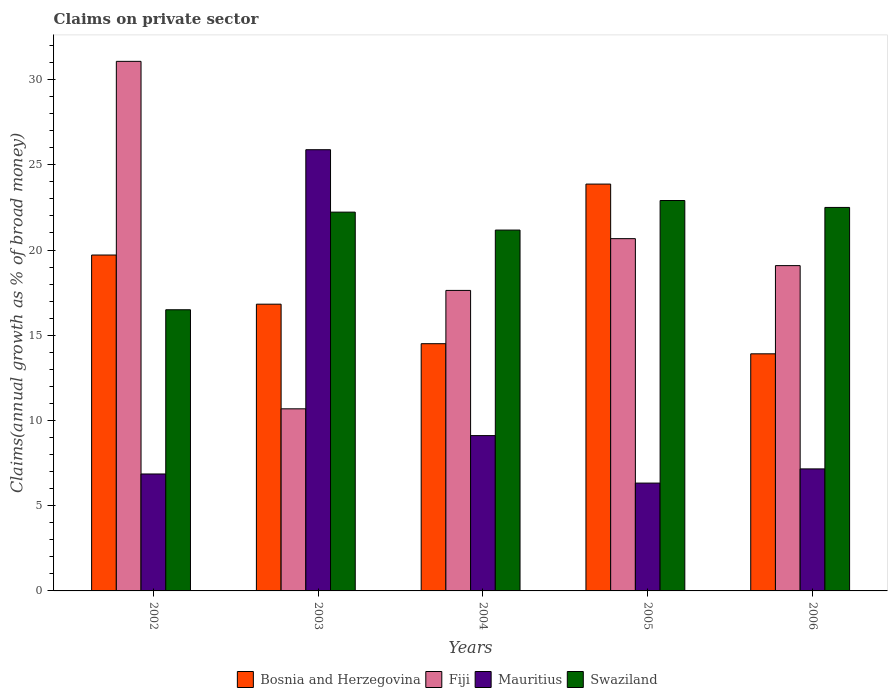Are the number of bars on each tick of the X-axis equal?
Ensure brevity in your answer.  Yes. How many bars are there on the 4th tick from the left?
Make the answer very short. 4. What is the percentage of broad money claimed on private sector in Swaziland in 2006?
Offer a very short reply. 22.5. Across all years, what is the maximum percentage of broad money claimed on private sector in Bosnia and Herzegovina?
Your response must be concise. 23.87. Across all years, what is the minimum percentage of broad money claimed on private sector in Swaziland?
Give a very brief answer. 16.49. In which year was the percentage of broad money claimed on private sector in Swaziland maximum?
Give a very brief answer. 2005. What is the total percentage of broad money claimed on private sector in Mauritius in the graph?
Offer a terse response. 55.34. What is the difference between the percentage of broad money claimed on private sector in Mauritius in 2005 and that in 2006?
Your answer should be compact. -0.83. What is the difference between the percentage of broad money claimed on private sector in Fiji in 2003 and the percentage of broad money claimed on private sector in Mauritius in 2004?
Make the answer very short. 1.57. What is the average percentage of broad money claimed on private sector in Mauritius per year?
Give a very brief answer. 11.07. In the year 2002, what is the difference between the percentage of broad money claimed on private sector in Fiji and percentage of broad money claimed on private sector in Bosnia and Herzegovina?
Keep it short and to the point. 11.36. What is the ratio of the percentage of broad money claimed on private sector in Fiji in 2003 to that in 2006?
Give a very brief answer. 0.56. Is the difference between the percentage of broad money claimed on private sector in Fiji in 2002 and 2003 greater than the difference between the percentage of broad money claimed on private sector in Bosnia and Herzegovina in 2002 and 2003?
Keep it short and to the point. Yes. What is the difference between the highest and the second highest percentage of broad money claimed on private sector in Bosnia and Herzegovina?
Provide a succinct answer. 4.16. What is the difference between the highest and the lowest percentage of broad money claimed on private sector in Swaziland?
Offer a terse response. 6.41. Is the sum of the percentage of broad money claimed on private sector in Bosnia and Herzegovina in 2005 and 2006 greater than the maximum percentage of broad money claimed on private sector in Mauritius across all years?
Offer a very short reply. Yes. What does the 1st bar from the left in 2006 represents?
Offer a terse response. Bosnia and Herzegovina. What does the 4th bar from the right in 2003 represents?
Your answer should be very brief. Bosnia and Herzegovina. Are all the bars in the graph horizontal?
Ensure brevity in your answer.  No. How many years are there in the graph?
Your answer should be compact. 5. Are the values on the major ticks of Y-axis written in scientific E-notation?
Your answer should be compact. No. Does the graph contain any zero values?
Provide a succinct answer. No. Does the graph contain grids?
Offer a terse response. No. How many legend labels are there?
Your answer should be compact. 4. How are the legend labels stacked?
Provide a short and direct response. Horizontal. What is the title of the graph?
Keep it short and to the point. Claims on private sector. What is the label or title of the X-axis?
Make the answer very short. Years. What is the label or title of the Y-axis?
Offer a terse response. Claims(annual growth as % of broad money). What is the Claims(annual growth as % of broad money) in Bosnia and Herzegovina in 2002?
Offer a terse response. 19.71. What is the Claims(annual growth as % of broad money) in Fiji in 2002?
Provide a succinct answer. 31.07. What is the Claims(annual growth as % of broad money) of Mauritius in 2002?
Ensure brevity in your answer.  6.86. What is the Claims(annual growth as % of broad money) of Swaziland in 2002?
Give a very brief answer. 16.49. What is the Claims(annual growth as % of broad money) in Bosnia and Herzegovina in 2003?
Ensure brevity in your answer.  16.82. What is the Claims(annual growth as % of broad money) in Fiji in 2003?
Give a very brief answer. 10.68. What is the Claims(annual growth as % of broad money) of Mauritius in 2003?
Give a very brief answer. 25.88. What is the Claims(annual growth as % of broad money) of Swaziland in 2003?
Offer a very short reply. 22.22. What is the Claims(annual growth as % of broad money) of Bosnia and Herzegovina in 2004?
Make the answer very short. 14.5. What is the Claims(annual growth as % of broad money) of Fiji in 2004?
Ensure brevity in your answer.  17.63. What is the Claims(annual growth as % of broad money) in Mauritius in 2004?
Offer a very short reply. 9.11. What is the Claims(annual growth as % of broad money) of Swaziland in 2004?
Make the answer very short. 21.17. What is the Claims(annual growth as % of broad money) in Bosnia and Herzegovina in 2005?
Make the answer very short. 23.87. What is the Claims(annual growth as % of broad money) in Fiji in 2005?
Ensure brevity in your answer.  20.67. What is the Claims(annual growth as % of broad money) in Mauritius in 2005?
Offer a very short reply. 6.33. What is the Claims(annual growth as % of broad money) of Swaziland in 2005?
Provide a short and direct response. 22.9. What is the Claims(annual growth as % of broad money) in Bosnia and Herzegovina in 2006?
Your response must be concise. 13.91. What is the Claims(annual growth as % of broad money) of Fiji in 2006?
Give a very brief answer. 19.09. What is the Claims(annual growth as % of broad money) in Mauritius in 2006?
Your answer should be very brief. 7.16. What is the Claims(annual growth as % of broad money) in Swaziland in 2006?
Your response must be concise. 22.5. Across all years, what is the maximum Claims(annual growth as % of broad money) of Bosnia and Herzegovina?
Your answer should be very brief. 23.87. Across all years, what is the maximum Claims(annual growth as % of broad money) in Fiji?
Offer a terse response. 31.07. Across all years, what is the maximum Claims(annual growth as % of broad money) of Mauritius?
Provide a succinct answer. 25.88. Across all years, what is the maximum Claims(annual growth as % of broad money) in Swaziland?
Provide a short and direct response. 22.9. Across all years, what is the minimum Claims(annual growth as % of broad money) of Bosnia and Herzegovina?
Keep it short and to the point. 13.91. Across all years, what is the minimum Claims(annual growth as % of broad money) of Fiji?
Your response must be concise. 10.68. Across all years, what is the minimum Claims(annual growth as % of broad money) in Mauritius?
Ensure brevity in your answer.  6.33. Across all years, what is the minimum Claims(annual growth as % of broad money) in Swaziland?
Make the answer very short. 16.49. What is the total Claims(annual growth as % of broad money) in Bosnia and Herzegovina in the graph?
Your answer should be compact. 88.81. What is the total Claims(annual growth as % of broad money) of Fiji in the graph?
Provide a short and direct response. 99.13. What is the total Claims(annual growth as % of broad money) of Mauritius in the graph?
Offer a terse response. 55.34. What is the total Claims(annual growth as % of broad money) of Swaziland in the graph?
Provide a succinct answer. 105.29. What is the difference between the Claims(annual growth as % of broad money) in Bosnia and Herzegovina in 2002 and that in 2003?
Keep it short and to the point. 2.88. What is the difference between the Claims(annual growth as % of broad money) in Fiji in 2002 and that in 2003?
Provide a short and direct response. 20.39. What is the difference between the Claims(annual growth as % of broad money) of Mauritius in 2002 and that in 2003?
Provide a short and direct response. -19.02. What is the difference between the Claims(annual growth as % of broad money) of Swaziland in 2002 and that in 2003?
Ensure brevity in your answer.  -5.73. What is the difference between the Claims(annual growth as % of broad money) in Bosnia and Herzegovina in 2002 and that in 2004?
Offer a terse response. 5.2. What is the difference between the Claims(annual growth as % of broad money) in Fiji in 2002 and that in 2004?
Your answer should be very brief. 13.44. What is the difference between the Claims(annual growth as % of broad money) of Mauritius in 2002 and that in 2004?
Your answer should be very brief. -2.25. What is the difference between the Claims(annual growth as % of broad money) of Swaziland in 2002 and that in 2004?
Your response must be concise. -4.68. What is the difference between the Claims(annual growth as % of broad money) of Bosnia and Herzegovina in 2002 and that in 2005?
Make the answer very short. -4.16. What is the difference between the Claims(annual growth as % of broad money) in Fiji in 2002 and that in 2005?
Provide a succinct answer. 10.4. What is the difference between the Claims(annual growth as % of broad money) in Mauritius in 2002 and that in 2005?
Offer a very short reply. 0.53. What is the difference between the Claims(annual growth as % of broad money) in Swaziland in 2002 and that in 2005?
Provide a short and direct response. -6.41. What is the difference between the Claims(annual growth as % of broad money) of Bosnia and Herzegovina in 2002 and that in 2006?
Give a very brief answer. 5.8. What is the difference between the Claims(annual growth as % of broad money) in Fiji in 2002 and that in 2006?
Ensure brevity in your answer.  11.98. What is the difference between the Claims(annual growth as % of broad money) in Mauritius in 2002 and that in 2006?
Provide a short and direct response. -0.3. What is the difference between the Claims(annual growth as % of broad money) of Swaziland in 2002 and that in 2006?
Ensure brevity in your answer.  -6. What is the difference between the Claims(annual growth as % of broad money) in Bosnia and Herzegovina in 2003 and that in 2004?
Give a very brief answer. 2.32. What is the difference between the Claims(annual growth as % of broad money) in Fiji in 2003 and that in 2004?
Your response must be concise. -6.95. What is the difference between the Claims(annual growth as % of broad money) of Mauritius in 2003 and that in 2004?
Keep it short and to the point. 16.77. What is the difference between the Claims(annual growth as % of broad money) of Swaziland in 2003 and that in 2004?
Make the answer very short. 1.05. What is the difference between the Claims(annual growth as % of broad money) in Bosnia and Herzegovina in 2003 and that in 2005?
Your response must be concise. -7.05. What is the difference between the Claims(annual growth as % of broad money) in Fiji in 2003 and that in 2005?
Provide a succinct answer. -9.98. What is the difference between the Claims(annual growth as % of broad money) in Mauritius in 2003 and that in 2005?
Offer a very short reply. 19.56. What is the difference between the Claims(annual growth as % of broad money) in Swaziland in 2003 and that in 2005?
Your response must be concise. -0.68. What is the difference between the Claims(annual growth as % of broad money) in Bosnia and Herzegovina in 2003 and that in 2006?
Your answer should be compact. 2.91. What is the difference between the Claims(annual growth as % of broad money) of Fiji in 2003 and that in 2006?
Provide a short and direct response. -8.4. What is the difference between the Claims(annual growth as % of broad money) in Mauritius in 2003 and that in 2006?
Your answer should be very brief. 18.73. What is the difference between the Claims(annual growth as % of broad money) in Swaziland in 2003 and that in 2006?
Your answer should be very brief. -0.28. What is the difference between the Claims(annual growth as % of broad money) of Bosnia and Herzegovina in 2004 and that in 2005?
Your answer should be compact. -9.36. What is the difference between the Claims(annual growth as % of broad money) in Fiji in 2004 and that in 2005?
Offer a very short reply. -3.04. What is the difference between the Claims(annual growth as % of broad money) in Mauritius in 2004 and that in 2005?
Your answer should be compact. 2.79. What is the difference between the Claims(annual growth as % of broad money) of Swaziland in 2004 and that in 2005?
Provide a succinct answer. -1.73. What is the difference between the Claims(annual growth as % of broad money) in Bosnia and Herzegovina in 2004 and that in 2006?
Give a very brief answer. 0.59. What is the difference between the Claims(annual growth as % of broad money) in Fiji in 2004 and that in 2006?
Your answer should be very brief. -1.45. What is the difference between the Claims(annual growth as % of broad money) in Mauritius in 2004 and that in 2006?
Offer a very short reply. 1.95. What is the difference between the Claims(annual growth as % of broad money) of Swaziland in 2004 and that in 2006?
Keep it short and to the point. -1.33. What is the difference between the Claims(annual growth as % of broad money) in Bosnia and Herzegovina in 2005 and that in 2006?
Provide a succinct answer. 9.96. What is the difference between the Claims(annual growth as % of broad money) of Fiji in 2005 and that in 2006?
Offer a terse response. 1.58. What is the difference between the Claims(annual growth as % of broad money) in Mauritius in 2005 and that in 2006?
Ensure brevity in your answer.  -0.83. What is the difference between the Claims(annual growth as % of broad money) of Swaziland in 2005 and that in 2006?
Give a very brief answer. 0.41. What is the difference between the Claims(annual growth as % of broad money) in Bosnia and Herzegovina in 2002 and the Claims(annual growth as % of broad money) in Fiji in 2003?
Your answer should be very brief. 9.02. What is the difference between the Claims(annual growth as % of broad money) of Bosnia and Herzegovina in 2002 and the Claims(annual growth as % of broad money) of Mauritius in 2003?
Provide a succinct answer. -6.18. What is the difference between the Claims(annual growth as % of broad money) in Bosnia and Herzegovina in 2002 and the Claims(annual growth as % of broad money) in Swaziland in 2003?
Offer a very short reply. -2.52. What is the difference between the Claims(annual growth as % of broad money) in Fiji in 2002 and the Claims(annual growth as % of broad money) in Mauritius in 2003?
Keep it short and to the point. 5.18. What is the difference between the Claims(annual growth as % of broad money) in Fiji in 2002 and the Claims(annual growth as % of broad money) in Swaziland in 2003?
Offer a very short reply. 8.85. What is the difference between the Claims(annual growth as % of broad money) in Mauritius in 2002 and the Claims(annual growth as % of broad money) in Swaziland in 2003?
Offer a very short reply. -15.36. What is the difference between the Claims(annual growth as % of broad money) of Bosnia and Herzegovina in 2002 and the Claims(annual growth as % of broad money) of Fiji in 2004?
Offer a very short reply. 2.08. What is the difference between the Claims(annual growth as % of broad money) of Bosnia and Herzegovina in 2002 and the Claims(annual growth as % of broad money) of Mauritius in 2004?
Keep it short and to the point. 10.59. What is the difference between the Claims(annual growth as % of broad money) of Bosnia and Herzegovina in 2002 and the Claims(annual growth as % of broad money) of Swaziland in 2004?
Give a very brief answer. -1.46. What is the difference between the Claims(annual growth as % of broad money) of Fiji in 2002 and the Claims(annual growth as % of broad money) of Mauritius in 2004?
Your answer should be very brief. 21.96. What is the difference between the Claims(annual growth as % of broad money) of Fiji in 2002 and the Claims(annual growth as % of broad money) of Swaziland in 2004?
Your answer should be compact. 9.9. What is the difference between the Claims(annual growth as % of broad money) in Mauritius in 2002 and the Claims(annual growth as % of broad money) in Swaziland in 2004?
Give a very brief answer. -14.31. What is the difference between the Claims(annual growth as % of broad money) of Bosnia and Herzegovina in 2002 and the Claims(annual growth as % of broad money) of Fiji in 2005?
Your response must be concise. -0.96. What is the difference between the Claims(annual growth as % of broad money) in Bosnia and Herzegovina in 2002 and the Claims(annual growth as % of broad money) in Mauritius in 2005?
Give a very brief answer. 13.38. What is the difference between the Claims(annual growth as % of broad money) in Bosnia and Herzegovina in 2002 and the Claims(annual growth as % of broad money) in Swaziland in 2005?
Provide a succinct answer. -3.2. What is the difference between the Claims(annual growth as % of broad money) of Fiji in 2002 and the Claims(annual growth as % of broad money) of Mauritius in 2005?
Your answer should be compact. 24.74. What is the difference between the Claims(annual growth as % of broad money) of Fiji in 2002 and the Claims(annual growth as % of broad money) of Swaziland in 2005?
Give a very brief answer. 8.16. What is the difference between the Claims(annual growth as % of broad money) in Mauritius in 2002 and the Claims(annual growth as % of broad money) in Swaziland in 2005?
Provide a succinct answer. -16.04. What is the difference between the Claims(annual growth as % of broad money) in Bosnia and Herzegovina in 2002 and the Claims(annual growth as % of broad money) in Fiji in 2006?
Give a very brief answer. 0.62. What is the difference between the Claims(annual growth as % of broad money) in Bosnia and Herzegovina in 2002 and the Claims(annual growth as % of broad money) in Mauritius in 2006?
Ensure brevity in your answer.  12.55. What is the difference between the Claims(annual growth as % of broad money) of Bosnia and Herzegovina in 2002 and the Claims(annual growth as % of broad money) of Swaziland in 2006?
Offer a very short reply. -2.79. What is the difference between the Claims(annual growth as % of broad money) of Fiji in 2002 and the Claims(annual growth as % of broad money) of Mauritius in 2006?
Ensure brevity in your answer.  23.91. What is the difference between the Claims(annual growth as % of broad money) of Fiji in 2002 and the Claims(annual growth as % of broad money) of Swaziland in 2006?
Give a very brief answer. 8.57. What is the difference between the Claims(annual growth as % of broad money) of Mauritius in 2002 and the Claims(annual growth as % of broad money) of Swaziland in 2006?
Make the answer very short. -15.64. What is the difference between the Claims(annual growth as % of broad money) of Bosnia and Herzegovina in 2003 and the Claims(annual growth as % of broad money) of Fiji in 2004?
Make the answer very short. -0.81. What is the difference between the Claims(annual growth as % of broad money) of Bosnia and Herzegovina in 2003 and the Claims(annual growth as % of broad money) of Mauritius in 2004?
Ensure brevity in your answer.  7.71. What is the difference between the Claims(annual growth as % of broad money) of Bosnia and Herzegovina in 2003 and the Claims(annual growth as % of broad money) of Swaziland in 2004?
Keep it short and to the point. -4.35. What is the difference between the Claims(annual growth as % of broad money) in Fiji in 2003 and the Claims(annual growth as % of broad money) in Mauritius in 2004?
Offer a very short reply. 1.57. What is the difference between the Claims(annual growth as % of broad money) of Fiji in 2003 and the Claims(annual growth as % of broad money) of Swaziland in 2004?
Keep it short and to the point. -10.49. What is the difference between the Claims(annual growth as % of broad money) of Mauritius in 2003 and the Claims(annual growth as % of broad money) of Swaziland in 2004?
Provide a short and direct response. 4.71. What is the difference between the Claims(annual growth as % of broad money) in Bosnia and Herzegovina in 2003 and the Claims(annual growth as % of broad money) in Fiji in 2005?
Offer a very short reply. -3.84. What is the difference between the Claims(annual growth as % of broad money) of Bosnia and Herzegovina in 2003 and the Claims(annual growth as % of broad money) of Mauritius in 2005?
Ensure brevity in your answer.  10.5. What is the difference between the Claims(annual growth as % of broad money) in Bosnia and Herzegovina in 2003 and the Claims(annual growth as % of broad money) in Swaziland in 2005?
Ensure brevity in your answer.  -6.08. What is the difference between the Claims(annual growth as % of broad money) in Fiji in 2003 and the Claims(annual growth as % of broad money) in Mauritius in 2005?
Your response must be concise. 4.36. What is the difference between the Claims(annual growth as % of broad money) of Fiji in 2003 and the Claims(annual growth as % of broad money) of Swaziland in 2005?
Provide a succinct answer. -12.22. What is the difference between the Claims(annual growth as % of broad money) in Mauritius in 2003 and the Claims(annual growth as % of broad money) in Swaziland in 2005?
Give a very brief answer. 2.98. What is the difference between the Claims(annual growth as % of broad money) of Bosnia and Herzegovina in 2003 and the Claims(annual growth as % of broad money) of Fiji in 2006?
Offer a very short reply. -2.26. What is the difference between the Claims(annual growth as % of broad money) in Bosnia and Herzegovina in 2003 and the Claims(annual growth as % of broad money) in Mauritius in 2006?
Keep it short and to the point. 9.66. What is the difference between the Claims(annual growth as % of broad money) in Bosnia and Herzegovina in 2003 and the Claims(annual growth as % of broad money) in Swaziland in 2006?
Keep it short and to the point. -5.68. What is the difference between the Claims(annual growth as % of broad money) in Fiji in 2003 and the Claims(annual growth as % of broad money) in Mauritius in 2006?
Provide a short and direct response. 3.52. What is the difference between the Claims(annual growth as % of broad money) of Fiji in 2003 and the Claims(annual growth as % of broad money) of Swaziland in 2006?
Give a very brief answer. -11.82. What is the difference between the Claims(annual growth as % of broad money) of Mauritius in 2003 and the Claims(annual growth as % of broad money) of Swaziland in 2006?
Your answer should be very brief. 3.39. What is the difference between the Claims(annual growth as % of broad money) of Bosnia and Herzegovina in 2004 and the Claims(annual growth as % of broad money) of Fiji in 2005?
Provide a succinct answer. -6.16. What is the difference between the Claims(annual growth as % of broad money) of Bosnia and Herzegovina in 2004 and the Claims(annual growth as % of broad money) of Mauritius in 2005?
Make the answer very short. 8.18. What is the difference between the Claims(annual growth as % of broad money) of Bosnia and Herzegovina in 2004 and the Claims(annual growth as % of broad money) of Swaziland in 2005?
Make the answer very short. -8.4. What is the difference between the Claims(annual growth as % of broad money) of Fiji in 2004 and the Claims(annual growth as % of broad money) of Mauritius in 2005?
Provide a succinct answer. 11.3. What is the difference between the Claims(annual growth as % of broad money) of Fiji in 2004 and the Claims(annual growth as % of broad money) of Swaziland in 2005?
Your answer should be very brief. -5.27. What is the difference between the Claims(annual growth as % of broad money) of Mauritius in 2004 and the Claims(annual growth as % of broad money) of Swaziland in 2005?
Your answer should be compact. -13.79. What is the difference between the Claims(annual growth as % of broad money) of Bosnia and Herzegovina in 2004 and the Claims(annual growth as % of broad money) of Fiji in 2006?
Make the answer very short. -4.58. What is the difference between the Claims(annual growth as % of broad money) of Bosnia and Herzegovina in 2004 and the Claims(annual growth as % of broad money) of Mauritius in 2006?
Give a very brief answer. 7.35. What is the difference between the Claims(annual growth as % of broad money) in Bosnia and Herzegovina in 2004 and the Claims(annual growth as % of broad money) in Swaziland in 2006?
Make the answer very short. -8. What is the difference between the Claims(annual growth as % of broad money) in Fiji in 2004 and the Claims(annual growth as % of broad money) in Mauritius in 2006?
Offer a terse response. 10.47. What is the difference between the Claims(annual growth as % of broad money) of Fiji in 2004 and the Claims(annual growth as % of broad money) of Swaziland in 2006?
Ensure brevity in your answer.  -4.87. What is the difference between the Claims(annual growth as % of broad money) in Mauritius in 2004 and the Claims(annual growth as % of broad money) in Swaziland in 2006?
Your response must be concise. -13.39. What is the difference between the Claims(annual growth as % of broad money) in Bosnia and Herzegovina in 2005 and the Claims(annual growth as % of broad money) in Fiji in 2006?
Provide a succinct answer. 4.78. What is the difference between the Claims(annual growth as % of broad money) in Bosnia and Herzegovina in 2005 and the Claims(annual growth as % of broad money) in Mauritius in 2006?
Make the answer very short. 16.71. What is the difference between the Claims(annual growth as % of broad money) of Bosnia and Herzegovina in 2005 and the Claims(annual growth as % of broad money) of Swaziland in 2006?
Ensure brevity in your answer.  1.37. What is the difference between the Claims(annual growth as % of broad money) in Fiji in 2005 and the Claims(annual growth as % of broad money) in Mauritius in 2006?
Offer a terse response. 13.51. What is the difference between the Claims(annual growth as % of broad money) of Fiji in 2005 and the Claims(annual growth as % of broad money) of Swaziland in 2006?
Keep it short and to the point. -1.83. What is the difference between the Claims(annual growth as % of broad money) of Mauritius in 2005 and the Claims(annual growth as % of broad money) of Swaziland in 2006?
Provide a succinct answer. -16.17. What is the average Claims(annual growth as % of broad money) of Bosnia and Herzegovina per year?
Provide a short and direct response. 17.76. What is the average Claims(annual growth as % of broad money) in Fiji per year?
Your response must be concise. 19.83. What is the average Claims(annual growth as % of broad money) of Mauritius per year?
Your answer should be very brief. 11.07. What is the average Claims(annual growth as % of broad money) in Swaziland per year?
Your response must be concise. 21.06. In the year 2002, what is the difference between the Claims(annual growth as % of broad money) of Bosnia and Herzegovina and Claims(annual growth as % of broad money) of Fiji?
Make the answer very short. -11.36. In the year 2002, what is the difference between the Claims(annual growth as % of broad money) in Bosnia and Herzegovina and Claims(annual growth as % of broad money) in Mauritius?
Provide a succinct answer. 12.85. In the year 2002, what is the difference between the Claims(annual growth as % of broad money) of Bosnia and Herzegovina and Claims(annual growth as % of broad money) of Swaziland?
Keep it short and to the point. 3.21. In the year 2002, what is the difference between the Claims(annual growth as % of broad money) of Fiji and Claims(annual growth as % of broad money) of Mauritius?
Your answer should be compact. 24.21. In the year 2002, what is the difference between the Claims(annual growth as % of broad money) of Fiji and Claims(annual growth as % of broad money) of Swaziland?
Provide a short and direct response. 14.57. In the year 2002, what is the difference between the Claims(annual growth as % of broad money) in Mauritius and Claims(annual growth as % of broad money) in Swaziland?
Provide a succinct answer. -9.63. In the year 2003, what is the difference between the Claims(annual growth as % of broad money) in Bosnia and Herzegovina and Claims(annual growth as % of broad money) in Fiji?
Provide a short and direct response. 6.14. In the year 2003, what is the difference between the Claims(annual growth as % of broad money) in Bosnia and Herzegovina and Claims(annual growth as % of broad money) in Mauritius?
Ensure brevity in your answer.  -9.06. In the year 2003, what is the difference between the Claims(annual growth as % of broad money) in Bosnia and Herzegovina and Claims(annual growth as % of broad money) in Swaziland?
Your answer should be very brief. -5.4. In the year 2003, what is the difference between the Claims(annual growth as % of broad money) of Fiji and Claims(annual growth as % of broad money) of Mauritius?
Your response must be concise. -15.2. In the year 2003, what is the difference between the Claims(annual growth as % of broad money) in Fiji and Claims(annual growth as % of broad money) in Swaziland?
Ensure brevity in your answer.  -11.54. In the year 2003, what is the difference between the Claims(annual growth as % of broad money) of Mauritius and Claims(annual growth as % of broad money) of Swaziland?
Your answer should be compact. 3.66. In the year 2004, what is the difference between the Claims(annual growth as % of broad money) of Bosnia and Herzegovina and Claims(annual growth as % of broad money) of Fiji?
Provide a short and direct response. -3.13. In the year 2004, what is the difference between the Claims(annual growth as % of broad money) of Bosnia and Herzegovina and Claims(annual growth as % of broad money) of Mauritius?
Your answer should be compact. 5.39. In the year 2004, what is the difference between the Claims(annual growth as % of broad money) of Bosnia and Herzegovina and Claims(annual growth as % of broad money) of Swaziland?
Make the answer very short. -6.67. In the year 2004, what is the difference between the Claims(annual growth as % of broad money) of Fiji and Claims(annual growth as % of broad money) of Mauritius?
Keep it short and to the point. 8.52. In the year 2004, what is the difference between the Claims(annual growth as % of broad money) of Fiji and Claims(annual growth as % of broad money) of Swaziland?
Give a very brief answer. -3.54. In the year 2004, what is the difference between the Claims(annual growth as % of broad money) in Mauritius and Claims(annual growth as % of broad money) in Swaziland?
Offer a terse response. -12.06. In the year 2005, what is the difference between the Claims(annual growth as % of broad money) in Bosnia and Herzegovina and Claims(annual growth as % of broad money) in Fiji?
Offer a terse response. 3.2. In the year 2005, what is the difference between the Claims(annual growth as % of broad money) of Bosnia and Herzegovina and Claims(annual growth as % of broad money) of Mauritius?
Your response must be concise. 17.54. In the year 2005, what is the difference between the Claims(annual growth as % of broad money) of Bosnia and Herzegovina and Claims(annual growth as % of broad money) of Swaziland?
Keep it short and to the point. 0.96. In the year 2005, what is the difference between the Claims(annual growth as % of broad money) in Fiji and Claims(annual growth as % of broad money) in Mauritius?
Ensure brevity in your answer.  14.34. In the year 2005, what is the difference between the Claims(annual growth as % of broad money) in Fiji and Claims(annual growth as % of broad money) in Swaziland?
Your response must be concise. -2.24. In the year 2005, what is the difference between the Claims(annual growth as % of broad money) in Mauritius and Claims(annual growth as % of broad money) in Swaziland?
Ensure brevity in your answer.  -16.58. In the year 2006, what is the difference between the Claims(annual growth as % of broad money) of Bosnia and Herzegovina and Claims(annual growth as % of broad money) of Fiji?
Offer a very short reply. -5.17. In the year 2006, what is the difference between the Claims(annual growth as % of broad money) of Bosnia and Herzegovina and Claims(annual growth as % of broad money) of Mauritius?
Your response must be concise. 6.75. In the year 2006, what is the difference between the Claims(annual growth as % of broad money) in Bosnia and Herzegovina and Claims(annual growth as % of broad money) in Swaziland?
Offer a very short reply. -8.59. In the year 2006, what is the difference between the Claims(annual growth as % of broad money) of Fiji and Claims(annual growth as % of broad money) of Mauritius?
Provide a short and direct response. 11.93. In the year 2006, what is the difference between the Claims(annual growth as % of broad money) of Fiji and Claims(annual growth as % of broad money) of Swaziland?
Provide a succinct answer. -3.41. In the year 2006, what is the difference between the Claims(annual growth as % of broad money) in Mauritius and Claims(annual growth as % of broad money) in Swaziland?
Offer a very short reply. -15.34. What is the ratio of the Claims(annual growth as % of broad money) in Bosnia and Herzegovina in 2002 to that in 2003?
Provide a succinct answer. 1.17. What is the ratio of the Claims(annual growth as % of broad money) in Fiji in 2002 to that in 2003?
Your answer should be compact. 2.91. What is the ratio of the Claims(annual growth as % of broad money) in Mauritius in 2002 to that in 2003?
Your response must be concise. 0.27. What is the ratio of the Claims(annual growth as % of broad money) in Swaziland in 2002 to that in 2003?
Your response must be concise. 0.74. What is the ratio of the Claims(annual growth as % of broad money) in Bosnia and Herzegovina in 2002 to that in 2004?
Ensure brevity in your answer.  1.36. What is the ratio of the Claims(annual growth as % of broad money) in Fiji in 2002 to that in 2004?
Your response must be concise. 1.76. What is the ratio of the Claims(annual growth as % of broad money) of Mauritius in 2002 to that in 2004?
Your answer should be compact. 0.75. What is the ratio of the Claims(annual growth as % of broad money) of Swaziland in 2002 to that in 2004?
Make the answer very short. 0.78. What is the ratio of the Claims(annual growth as % of broad money) of Bosnia and Herzegovina in 2002 to that in 2005?
Keep it short and to the point. 0.83. What is the ratio of the Claims(annual growth as % of broad money) of Fiji in 2002 to that in 2005?
Make the answer very short. 1.5. What is the ratio of the Claims(annual growth as % of broad money) in Mauritius in 2002 to that in 2005?
Give a very brief answer. 1.08. What is the ratio of the Claims(annual growth as % of broad money) in Swaziland in 2002 to that in 2005?
Keep it short and to the point. 0.72. What is the ratio of the Claims(annual growth as % of broad money) in Bosnia and Herzegovina in 2002 to that in 2006?
Provide a short and direct response. 1.42. What is the ratio of the Claims(annual growth as % of broad money) in Fiji in 2002 to that in 2006?
Provide a succinct answer. 1.63. What is the ratio of the Claims(annual growth as % of broad money) in Mauritius in 2002 to that in 2006?
Offer a terse response. 0.96. What is the ratio of the Claims(annual growth as % of broad money) in Swaziland in 2002 to that in 2006?
Make the answer very short. 0.73. What is the ratio of the Claims(annual growth as % of broad money) of Bosnia and Herzegovina in 2003 to that in 2004?
Provide a succinct answer. 1.16. What is the ratio of the Claims(annual growth as % of broad money) in Fiji in 2003 to that in 2004?
Offer a very short reply. 0.61. What is the ratio of the Claims(annual growth as % of broad money) of Mauritius in 2003 to that in 2004?
Your answer should be very brief. 2.84. What is the ratio of the Claims(annual growth as % of broad money) of Swaziland in 2003 to that in 2004?
Offer a terse response. 1.05. What is the ratio of the Claims(annual growth as % of broad money) in Bosnia and Herzegovina in 2003 to that in 2005?
Offer a very short reply. 0.7. What is the ratio of the Claims(annual growth as % of broad money) of Fiji in 2003 to that in 2005?
Offer a terse response. 0.52. What is the ratio of the Claims(annual growth as % of broad money) in Mauritius in 2003 to that in 2005?
Keep it short and to the point. 4.09. What is the ratio of the Claims(annual growth as % of broad money) of Swaziland in 2003 to that in 2005?
Your response must be concise. 0.97. What is the ratio of the Claims(annual growth as % of broad money) of Bosnia and Herzegovina in 2003 to that in 2006?
Offer a very short reply. 1.21. What is the ratio of the Claims(annual growth as % of broad money) of Fiji in 2003 to that in 2006?
Give a very brief answer. 0.56. What is the ratio of the Claims(annual growth as % of broad money) of Mauritius in 2003 to that in 2006?
Keep it short and to the point. 3.62. What is the ratio of the Claims(annual growth as % of broad money) in Bosnia and Herzegovina in 2004 to that in 2005?
Make the answer very short. 0.61. What is the ratio of the Claims(annual growth as % of broad money) in Fiji in 2004 to that in 2005?
Keep it short and to the point. 0.85. What is the ratio of the Claims(annual growth as % of broad money) in Mauritius in 2004 to that in 2005?
Offer a terse response. 1.44. What is the ratio of the Claims(annual growth as % of broad money) of Swaziland in 2004 to that in 2005?
Make the answer very short. 0.92. What is the ratio of the Claims(annual growth as % of broad money) in Bosnia and Herzegovina in 2004 to that in 2006?
Your response must be concise. 1.04. What is the ratio of the Claims(annual growth as % of broad money) in Fiji in 2004 to that in 2006?
Provide a succinct answer. 0.92. What is the ratio of the Claims(annual growth as % of broad money) in Mauritius in 2004 to that in 2006?
Make the answer very short. 1.27. What is the ratio of the Claims(annual growth as % of broad money) of Swaziland in 2004 to that in 2006?
Make the answer very short. 0.94. What is the ratio of the Claims(annual growth as % of broad money) in Bosnia and Herzegovina in 2005 to that in 2006?
Your answer should be compact. 1.72. What is the ratio of the Claims(annual growth as % of broad money) of Fiji in 2005 to that in 2006?
Your response must be concise. 1.08. What is the ratio of the Claims(annual growth as % of broad money) of Mauritius in 2005 to that in 2006?
Ensure brevity in your answer.  0.88. What is the difference between the highest and the second highest Claims(annual growth as % of broad money) of Bosnia and Herzegovina?
Your response must be concise. 4.16. What is the difference between the highest and the second highest Claims(annual growth as % of broad money) of Fiji?
Give a very brief answer. 10.4. What is the difference between the highest and the second highest Claims(annual growth as % of broad money) in Mauritius?
Keep it short and to the point. 16.77. What is the difference between the highest and the second highest Claims(annual growth as % of broad money) in Swaziland?
Offer a very short reply. 0.41. What is the difference between the highest and the lowest Claims(annual growth as % of broad money) in Bosnia and Herzegovina?
Keep it short and to the point. 9.96. What is the difference between the highest and the lowest Claims(annual growth as % of broad money) in Fiji?
Give a very brief answer. 20.39. What is the difference between the highest and the lowest Claims(annual growth as % of broad money) in Mauritius?
Offer a very short reply. 19.56. What is the difference between the highest and the lowest Claims(annual growth as % of broad money) of Swaziland?
Provide a succinct answer. 6.41. 